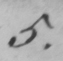Please provide the text content of this handwritten line. 5 . 